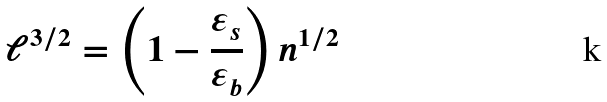<formula> <loc_0><loc_0><loc_500><loc_500>\ell ^ { 3 / 2 } = \left ( 1 - \frac { \varepsilon _ { s } } { \varepsilon _ { b } } \right ) n ^ { 1 / 2 }</formula> 